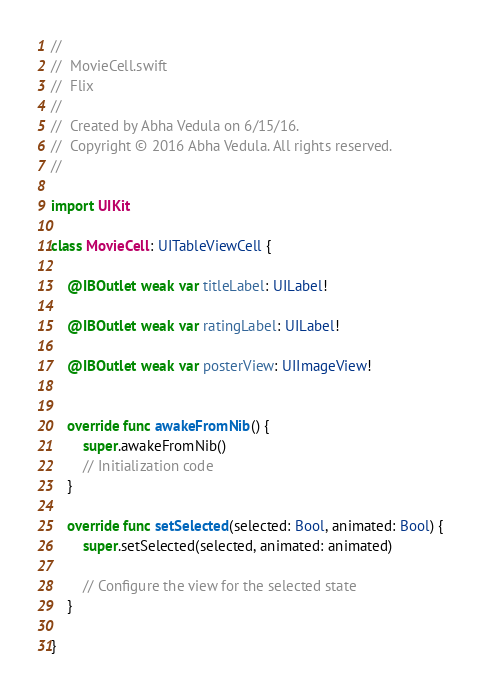<code> <loc_0><loc_0><loc_500><loc_500><_Swift_>//
//  MovieCell.swift
//  Flix
//
//  Created by Abha Vedula on 6/15/16.
//  Copyright © 2016 Abha Vedula. All rights reserved.
//

import UIKit

class MovieCell: UITableViewCell {
    
    @IBOutlet weak var titleLabel: UILabel!
    
    @IBOutlet weak var ratingLabel: UILabel!
    
    @IBOutlet weak var posterView: UIImageView!
    

    override func awakeFromNib() {
        super.awakeFromNib()
        // Initialization code
    }

    override func setSelected(selected: Bool, animated: Bool) {
        super.setSelected(selected, animated: animated)

        // Configure the view for the selected state
    }

}
</code> 